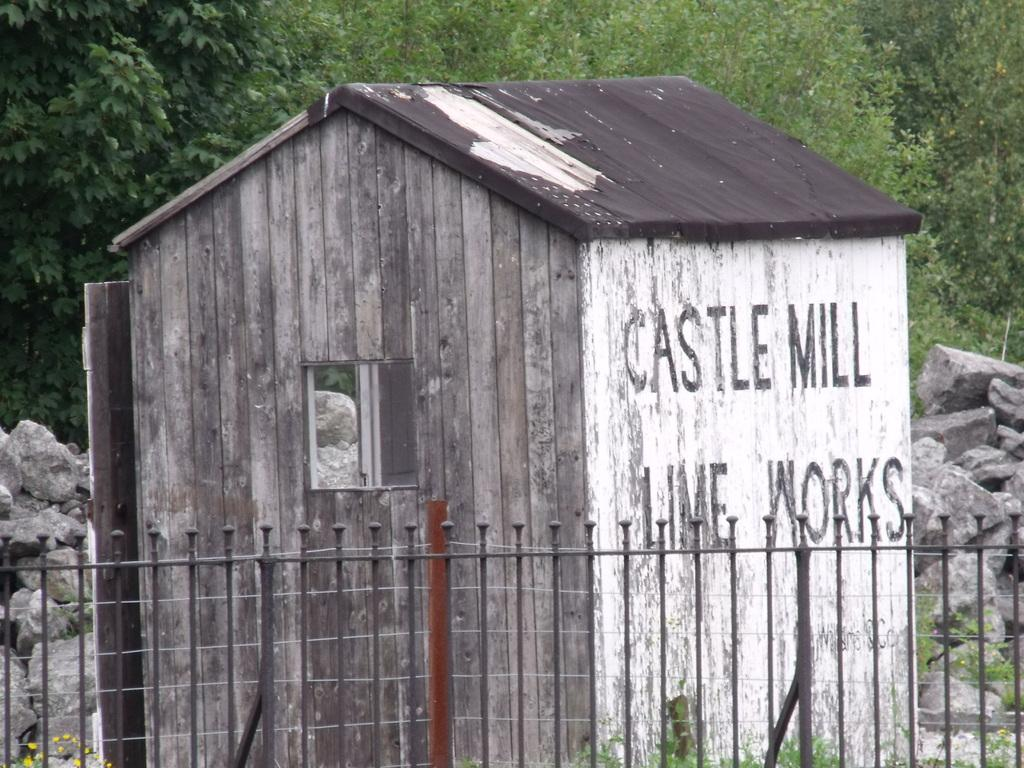<image>
Share a concise interpretation of the image provided. An small wooden structure says Castle Mill Lime Works on the side. 